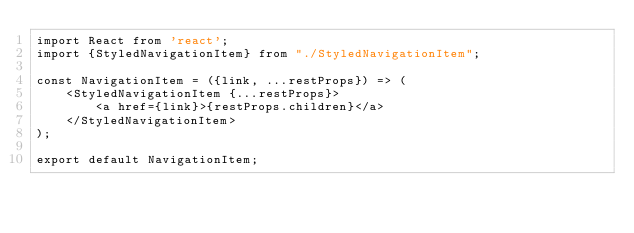Convert code to text. <code><loc_0><loc_0><loc_500><loc_500><_JavaScript_>import React from 'react';
import {StyledNavigationItem} from "./StyledNavigationItem";

const NavigationItem = ({link, ...restProps}) => (
    <StyledNavigationItem {...restProps}>
        <a href={link}>{restProps.children}</a>
    </StyledNavigationItem>
);

export default NavigationItem;</code> 